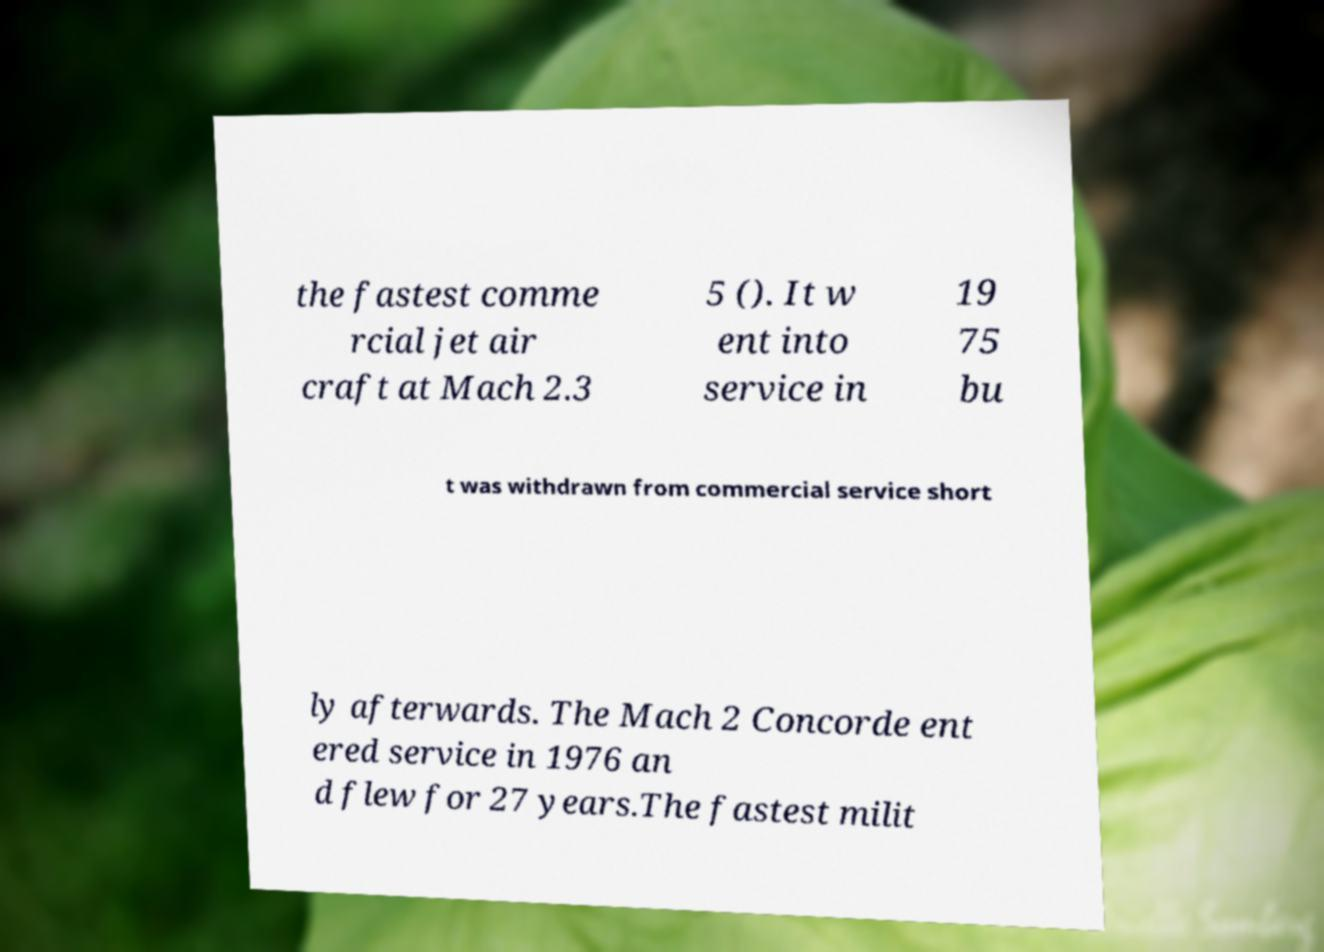There's text embedded in this image that I need extracted. Can you transcribe it verbatim? the fastest comme rcial jet air craft at Mach 2.3 5 (). It w ent into service in 19 75 bu t was withdrawn from commercial service short ly afterwards. The Mach 2 Concorde ent ered service in 1976 an d flew for 27 years.The fastest milit 